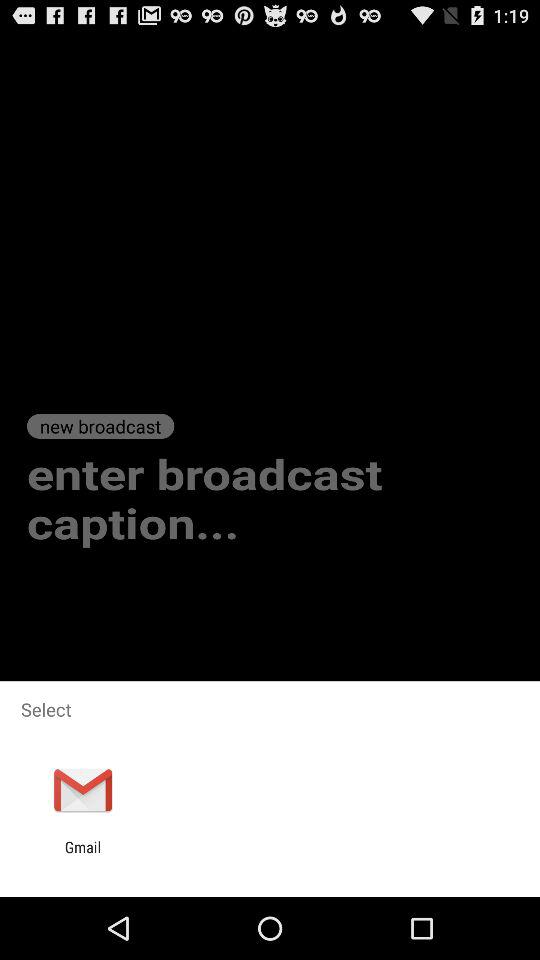What application can be selected? The application "Gmail" can be selected. 